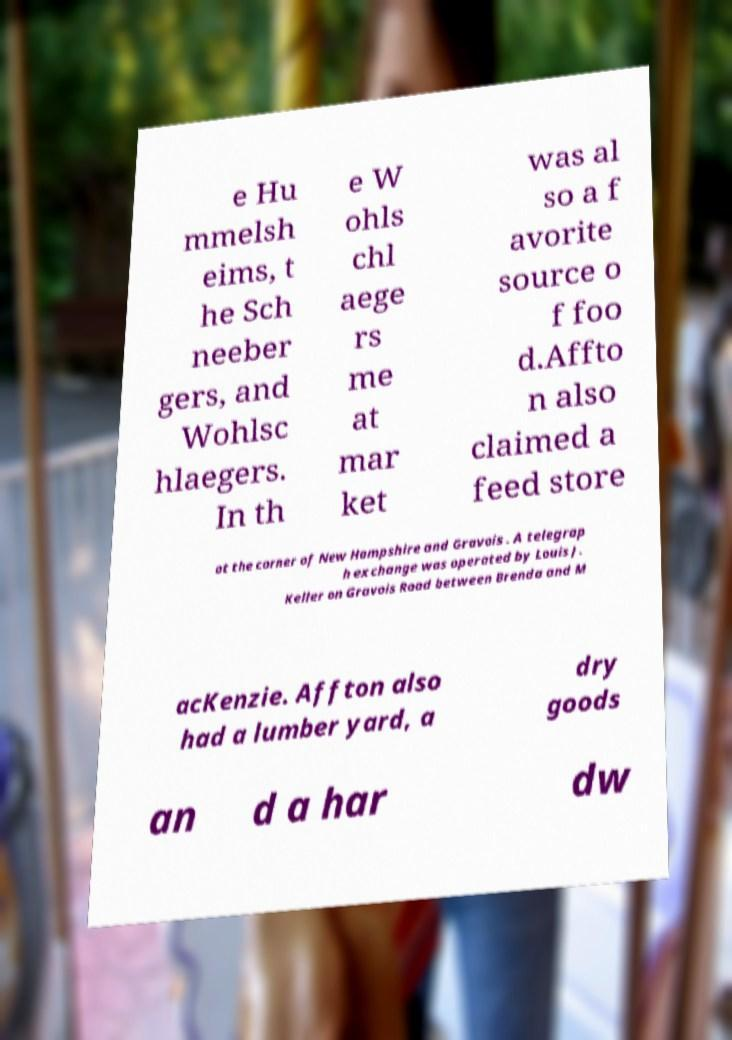What messages or text are displayed in this image? I need them in a readable, typed format. e Hu mmelsh eims, t he Sch neeber gers, and Wohlsc hlaegers. In th e W ohls chl aege rs me at mar ket was al so a f avorite source o f foo d.Affto n also claimed a feed store at the corner of New Hampshire and Gravois . A telegrap h exchange was operated by Louis J. Keller on Gravois Road between Brenda and M acKenzie. Affton also had a lumber yard, a dry goods an d a har dw 